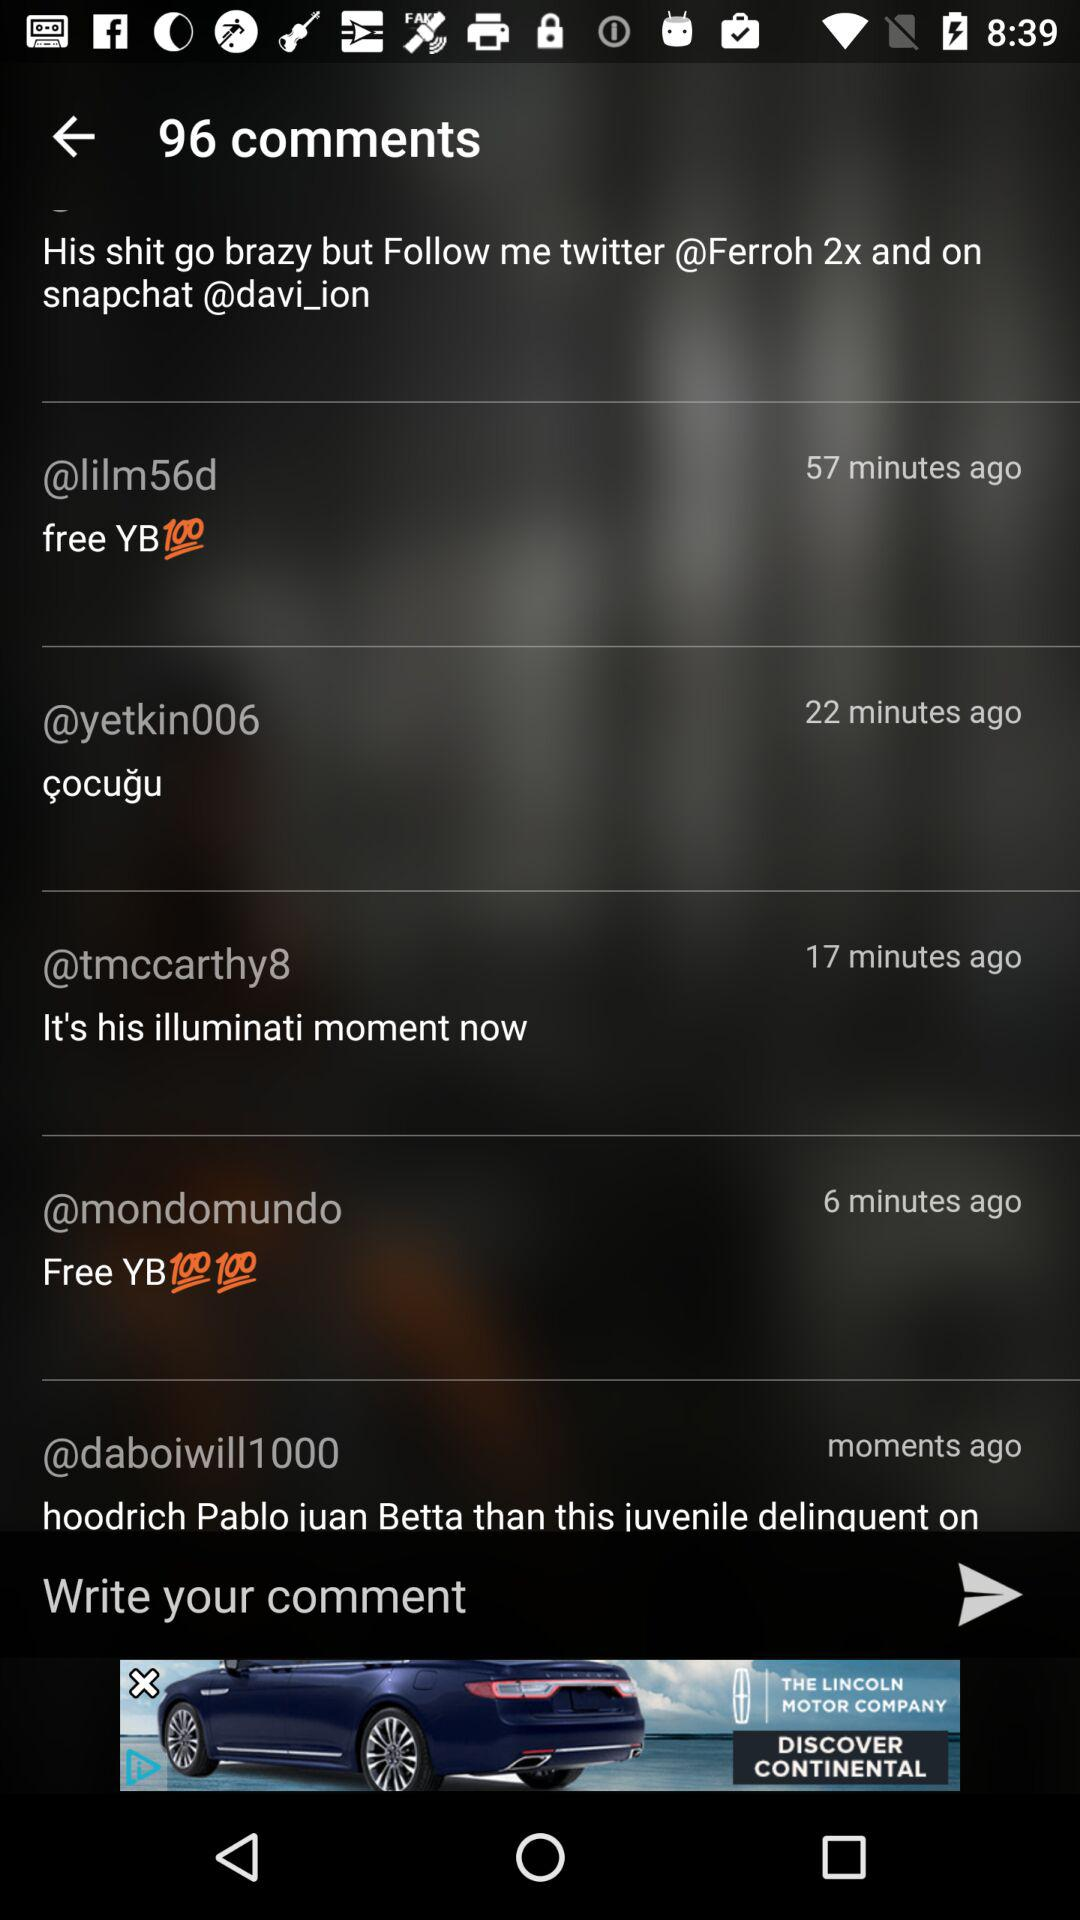What is the total count of comments? The total count is 96. 